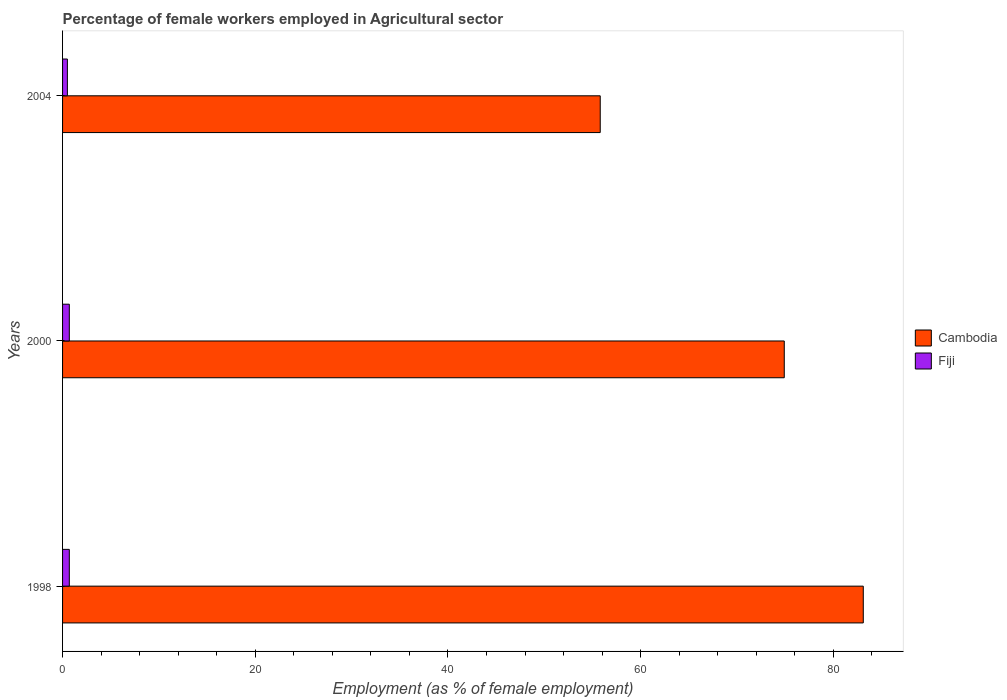Are the number of bars on each tick of the Y-axis equal?
Keep it short and to the point. Yes. How many bars are there on the 3rd tick from the bottom?
Your response must be concise. 2. What is the label of the 2nd group of bars from the top?
Ensure brevity in your answer.  2000. In how many cases, is the number of bars for a given year not equal to the number of legend labels?
Provide a short and direct response. 0. What is the percentage of females employed in Agricultural sector in Cambodia in 2004?
Your response must be concise. 55.8. Across all years, what is the maximum percentage of females employed in Agricultural sector in Fiji?
Your response must be concise. 0.7. Across all years, what is the minimum percentage of females employed in Agricultural sector in Fiji?
Your answer should be compact. 0.5. In which year was the percentage of females employed in Agricultural sector in Fiji maximum?
Your answer should be very brief. 1998. What is the total percentage of females employed in Agricultural sector in Cambodia in the graph?
Give a very brief answer. 213.8. What is the difference between the percentage of females employed in Agricultural sector in Cambodia in 1998 and that in 2000?
Your answer should be compact. 8.2. What is the difference between the percentage of females employed in Agricultural sector in Cambodia in 2000 and the percentage of females employed in Agricultural sector in Fiji in 1998?
Offer a very short reply. 74.2. What is the average percentage of females employed in Agricultural sector in Fiji per year?
Your answer should be compact. 0.63. In the year 1998, what is the difference between the percentage of females employed in Agricultural sector in Fiji and percentage of females employed in Agricultural sector in Cambodia?
Make the answer very short. -82.4. In how many years, is the percentage of females employed in Agricultural sector in Fiji greater than 4 %?
Provide a short and direct response. 0. What is the ratio of the percentage of females employed in Agricultural sector in Cambodia in 1998 to that in 2000?
Your answer should be very brief. 1.11. Is the percentage of females employed in Agricultural sector in Fiji in 1998 less than that in 2000?
Your answer should be very brief. No. What is the difference between the highest and the second highest percentage of females employed in Agricultural sector in Fiji?
Keep it short and to the point. 0. What is the difference between the highest and the lowest percentage of females employed in Agricultural sector in Cambodia?
Your answer should be very brief. 27.3. In how many years, is the percentage of females employed in Agricultural sector in Fiji greater than the average percentage of females employed in Agricultural sector in Fiji taken over all years?
Your answer should be compact. 2. Is the sum of the percentage of females employed in Agricultural sector in Fiji in 2000 and 2004 greater than the maximum percentage of females employed in Agricultural sector in Cambodia across all years?
Keep it short and to the point. No. What does the 2nd bar from the top in 2000 represents?
Your answer should be compact. Cambodia. What does the 2nd bar from the bottom in 2004 represents?
Ensure brevity in your answer.  Fiji. How many bars are there?
Your answer should be very brief. 6. Are all the bars in the graph horizontal?
Keep it short and to the point. Yes. What is the difference between two consecutive major ticks on the X-axis?
Your answer should be compact. 20. Does the graph contain any zero values?
Give a very brief answer. No. Where does the legend appear in the graph?
Keep it short and to the point. Center right. What is the title of the graph?
Offer a very short reply. Percentage of female workers employed in Agricultural sector. Does "South Africa" appear as one of the legend labels in the graph?
Ensure brevity in your answer.  No. What is the label or title of the X-axis?
Your answer should be very brief. Employment (as % of female employment). What is the Employment (as % of female employment) in Cambodia in 1998?
Your answer should be compact. 83.1. What is the Employment (as % of female employment) in Fiji in 1998?
Your answer should be very brief. 0.7. What is the Employment (as % of female employment) in Cambodia in 2000?
Give a very brief answer. 74.9. What is the Employment (as % of female employment) in Fiji in 2000?
Offer a terse response. 0.7. What is the Employment (as % of female employment) in Cambodia in 2004?
Provide a succinct answer. 55.8. What is the Employment (as % of female employment) of Fiji in 2004?
Provide a short and direct response. 0.5. Across all years, what is the maximum Employment (as % of female employment) in Cambodia?
Give a very brief answer. 83.1. Across all years, what is the maximum Employment (as % of female employment) of Fiji?
Your answer should be very brief. 0.7. Across all years, what is the minimum Employment (as % of female employment) of Cambodia?
Provide a succinct answer. 55.8. What is the total Employment (as % of female employment) in Cambodia in the graph?
Offer a terse response. 213.8. What is the total Employment (as % of female employment) of Fiji in the graph?
Offer a very short reply. 1.9. What is the difference between the Employment (as % of female employment) in Cambodia in 1998 and that in 2000?
Your response must be concise. 8.2. What is the difference between the Employment (as % of female employment) in Fiji in 1998 and that in 2000?
Offer a terse response. 0. What is the difference between the Employment (as % of female employment) of Cambodia in 1998 and that in 2004?
Your answer should be very brief. 27.3. What is the difference between the Employment (as % of female employment) of Fiji in 1998 and that in 2004?
Make the answer very short. 0.2. What is the difference between the Employment (as % of female employment) in Fiji in 2000 and that in 2004?
Keep it short and to the point. 0.2. What is the difference between the Employment (as % of female employment) in Cambodia in 1998 and the Employment (as % of female employment) in Fiji in 2000?
Provide a succinct answer. 82.4. What is the difference between the Employment (as % of female employment) in Cambodia in 1998 and the Employment (as % of female employment) in Fiji in 2004?
Offer a terse response. 82.6. What is the difference between the Employment (as % of female employment) in Cambodia in 2000 and the Employment (as % of female employment) in Fiji in 2004?
Your answer should be very brief. 74.4. What is the average Employment (as % of female employment) in Cambodia per year?
Ensure brevity in your answer.  71.27. What is the average Employment (as % of female employment) in Fiji per year?
Your answer should be very brief. 0.63. In the year 1998, what is the difference between the Employment (as % of female employment) in Cambodia and Employment (as % of female employment) in Fiji?
Offer a very short reply. 82.4. In the year 2000, what is the difference between the Employment (as % of female employment) in Cambodia and Employment (as % of female employment) in Fiji?
Make the answer very short. 74.2. In the year 2004, what is the difference between the Employment (as % of female employment) in Cambodia and Employment (as % of female employment) in Fiji?
Make the answer very short. 55.3. What is the ratio of the Employment (as % of female employment) in Cambodia in 1998 to that in 2000?
Make the answer very short. 1.11. What is the ratio of the Employment (as % of female employment) of Fiji in 1998 to that in 2000?
Give a very brief answer. 1. What is the ratio of the Employment (as % of female employment) of Cambodia in 1998 to that in 2004?
Provide a short and direct response. 1.49. What is the ratio of the Employment (as % of female employment) of Cambodia in 2000 to that in 2004?
Give a very brief answer. 1.34. What is the ratio of the Employment (as % of female employment) of Fiji in 2000 to that in 2004?
Your answer should be compact. 1.4. What is the difference between the highest and the lowest Employment (as % of female employment) in Cambodia?
Your answer should be compact. 27.3. 